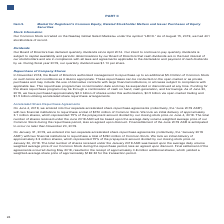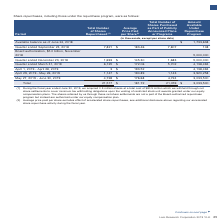According to Lam Research Corporation's financial document, What is the total number of shares repurchased? According to the financial document, 21,517 (in thousands). The relevant text states: "Total 21,517 $ 181.72 21,059 $ 3,033,500..." Also, What was the total cost of the shares that were withheld during the fiscal year ended June 30, 2019? According to the financial document, $80.5 million. The relevant text states: "we acquired 0.5 million shares at a total cost of $80.5 million which we withheld through net share settlements to cover minimum tax withholding obligations upon th..." Also, What will the total number of shares received under the June 2019 ASR will be based upon? the average daily volume weighted average price of our Common Stock during the repurchase period, less an agreed upon discount. The document states: "ceived under the June 2019 ASR will be based upon the average daily volume weighted average price of our Common Stock during the repurchase period, le..." Also, can you calculate: What is the percentage of shares repurchased in Quarter ended December 23, 2018 in the total repurchased shares? Based on the calculation: 1,693/21,517, the result is 7.87 (percentage). This is based on the information: "Quarter ended December 23, 2018 1,693 $ 145.30 1,683 5,000,000 Total 21,517 $ 181.72 21,059 $ 3,033,500..." The key data points involved are: 1,693, 21,517. Also, can you calculate: What is the percentage of shares repurchased within May 27, 2019 - June 30, 2019 in the total repurchased shares? Based on the calculation: 4,728/21,517, the result is 21.97 (percentage). This is based on the information: "May 27, 2019 - June 30, 2019 4,728 $ 176.68 4,724 3,033,500 Total 21,517 $ 181.72 21,059 $ 3,033,500..." The key data points involved are: 21,517, 4,728. Also, can you calculate: What is the percentage of the Total Number of Shares Purchased as Part of Publicly Announced Plans or Programs in the Total Number of Shares Repurchased? Based on the calculation: 21,059/21,517, the result is 97.87 (percentage). This is based on the information: "Total 21,517 $ 181.72 21,059 $ 3,033,500 Total 21,517 $ 181.72 21,059 $ 3,033,500..." The key data points involved are: 21,059, 21,517. 